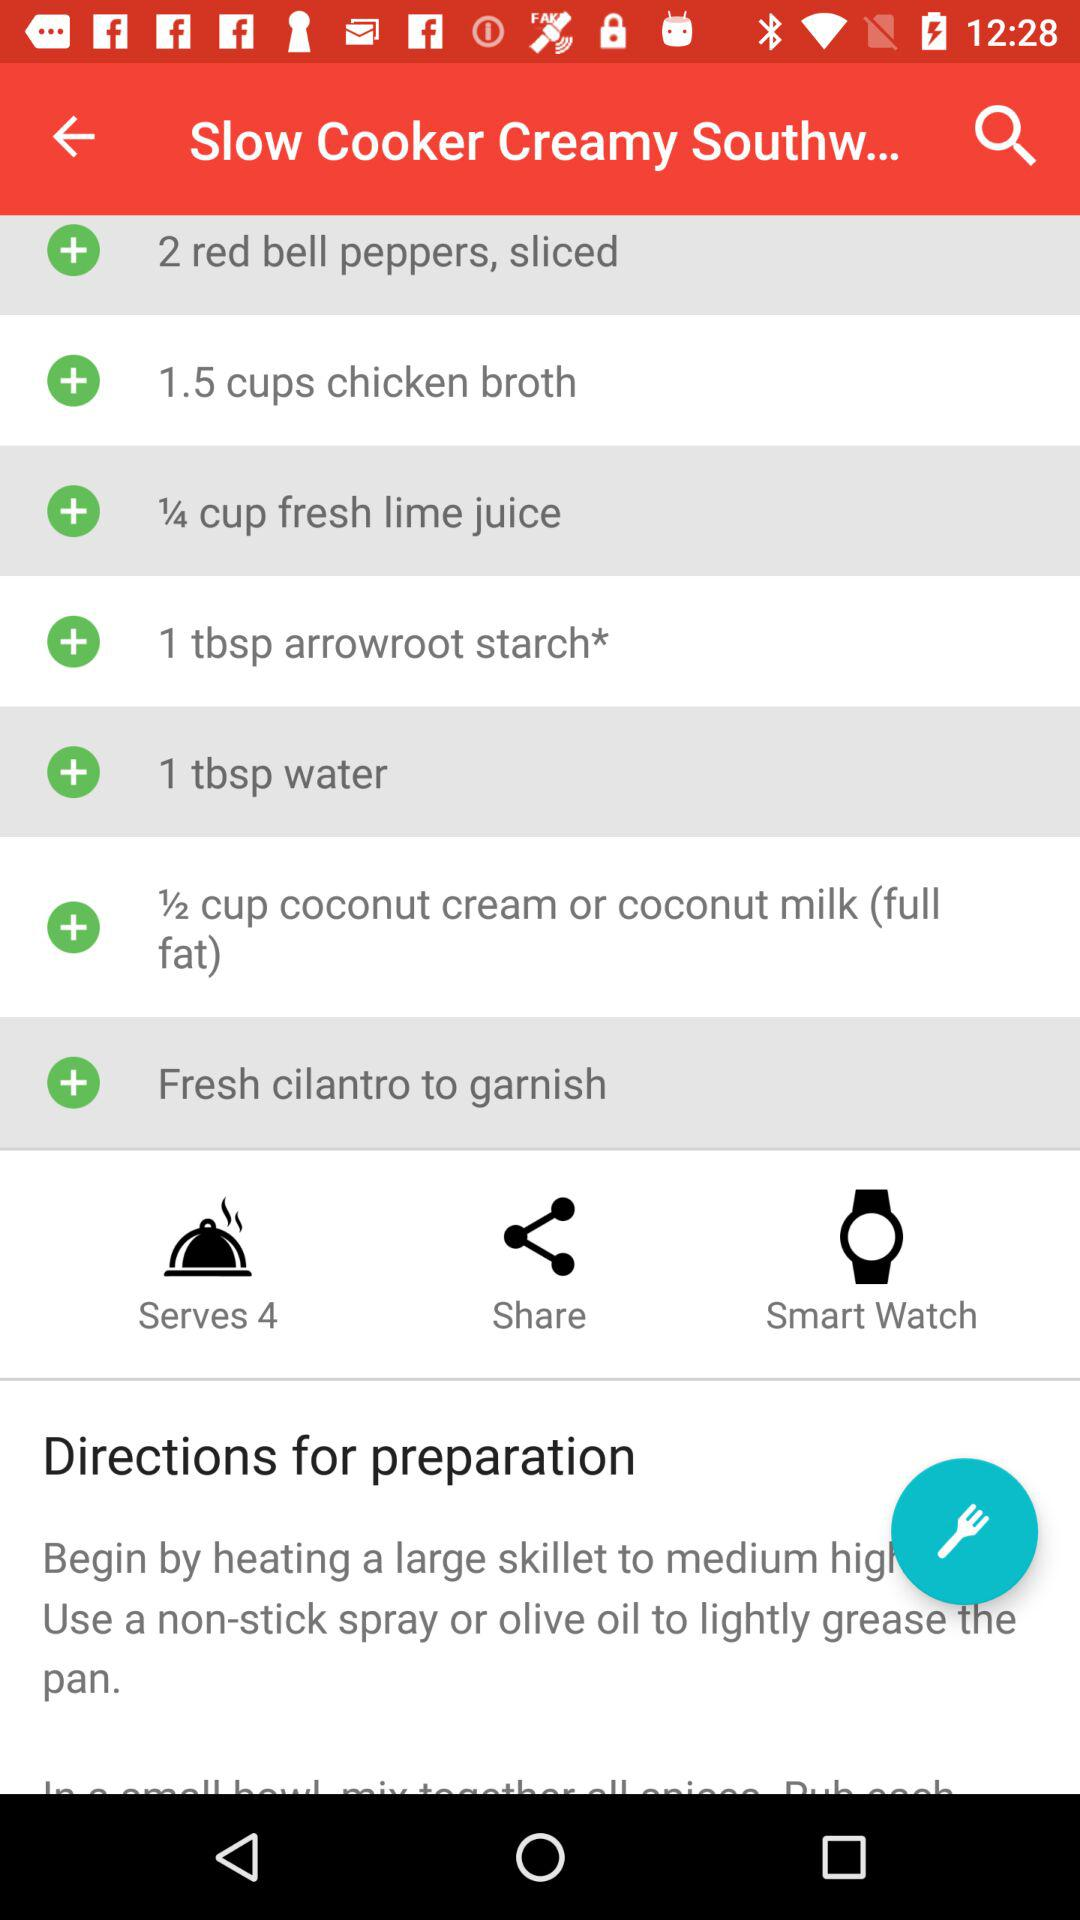What is the name of the recipe? The name of the recipe is "Slow Cooker Creamy Southw...". 